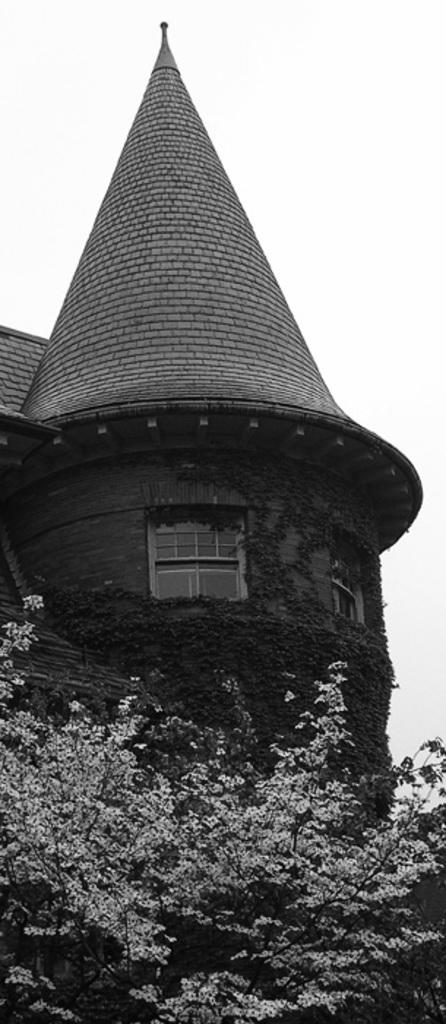What is the color scheme of the image? The image is black and white. What can be seen at the bottom of the image? There are tree branches at the bottom of the image. What is visible in the background of the image? In the background of the image, there is a building, roofs, windows, plants, and the sky. What type of substance is being cast into the sea in the image? There is no substance being cast into the sea in the image, as it does not depict any such activity. 